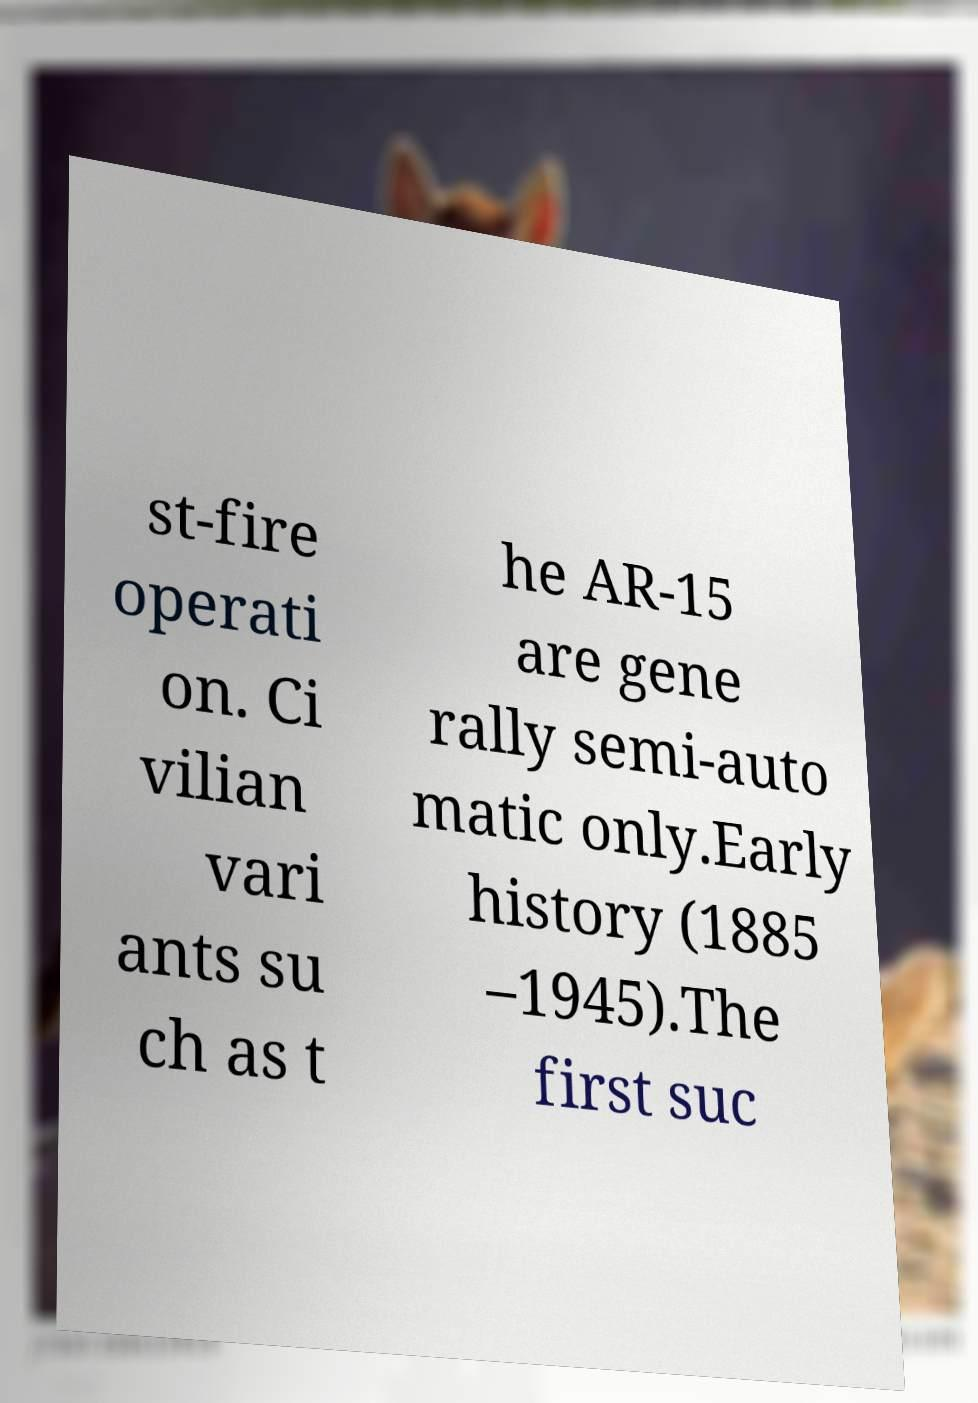I need the written content from this picture converted into text. Can you do that? st-fire operati on. Ci vilian vari ants su ch as t he AR-15 are gene rally semi-auto matic only.Early history (1885 –1945).The first suc 